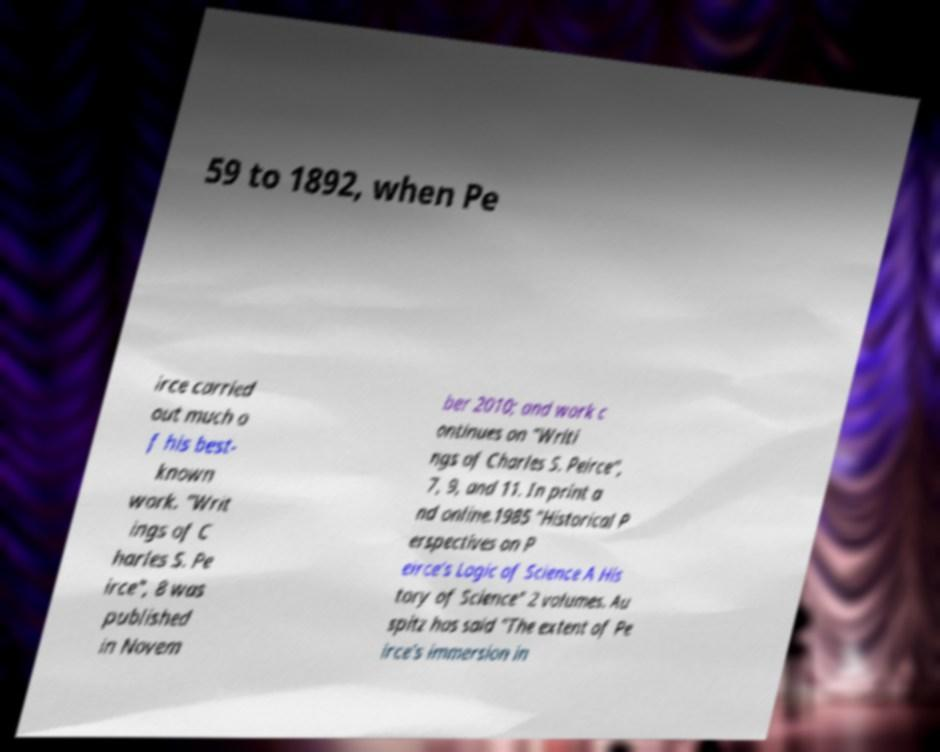There's text embedded in this image that I need extracted. Can you transcribe it verbatim? 59 to 1892, when Pe irce carried out much o f his best- known work. "Writ ings of C harles S. Pe irce", 8 was published in Novem ber 2010; and work c ontinues on "Writi ngs of Charles S. Peirce", 7, 9, and 11. In print a nd online.1985 "Historical P erspectives on P eirce's Logic of Science A His tory of Science" 2 volumes. Au spitz has said "The extent of Pe irce's immersion in 